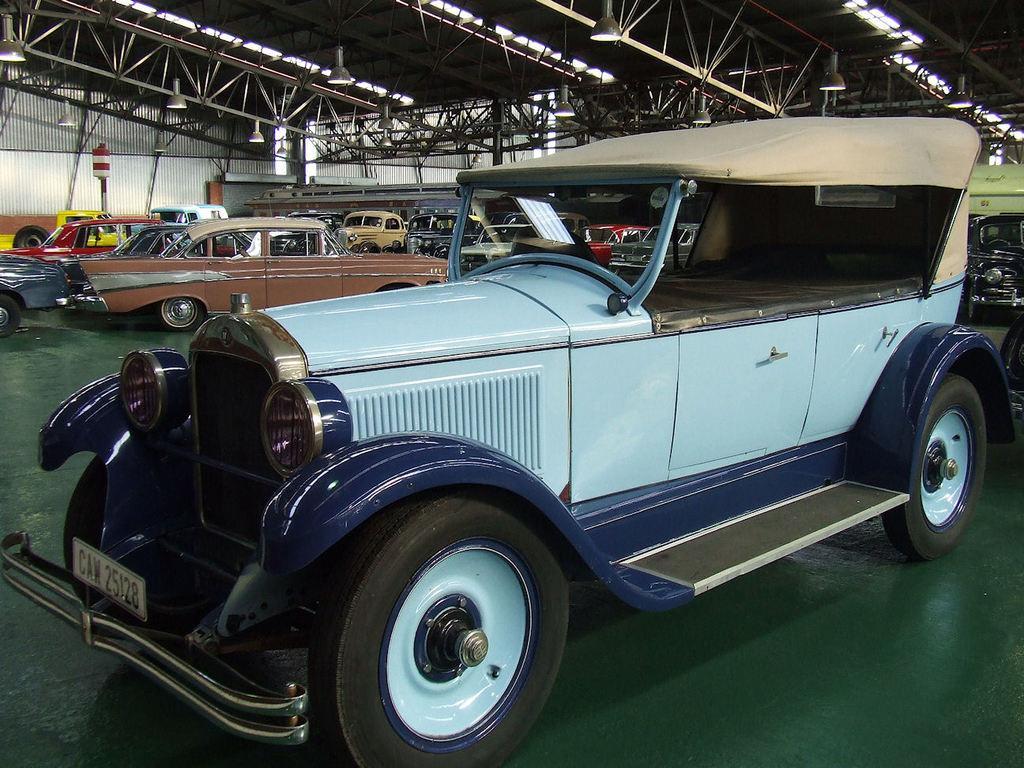Could you give a brief overview of what you see in this image? In this image, we can see so many vehicles on the floor. Background we can see a pole. Top of the image, we can see rods and lights. 